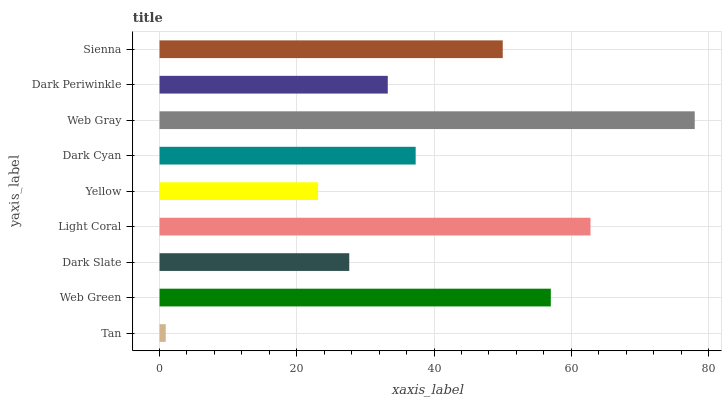Is Tan the minimum?
Answer yes or no. Yes. Is Web Gray the maximum?
Answer yes or no. Yes. Is Web Green the minimum?
Answer yes or no. No. Is Web Green the maximum?
Answer yes or no. No. Is Web Green greater than Tan?
Answer yes or no. Yes. Is Tan less than Web Green?
Answer yes or no. Yes. Is Tan greater than Web Green?
Answer yes or no. No. Is Web Green less than Tan?
Answer yes or no. No. Is Dark Cyan the high median?
Answer yes or no. Yes. Is Dark Cyan the low median?
Answer yes or no. Yes. Is Dark Periwinkle the high median?
Answer yes or no. No. Is Sienna the low median?
Answer yes or no. No. 